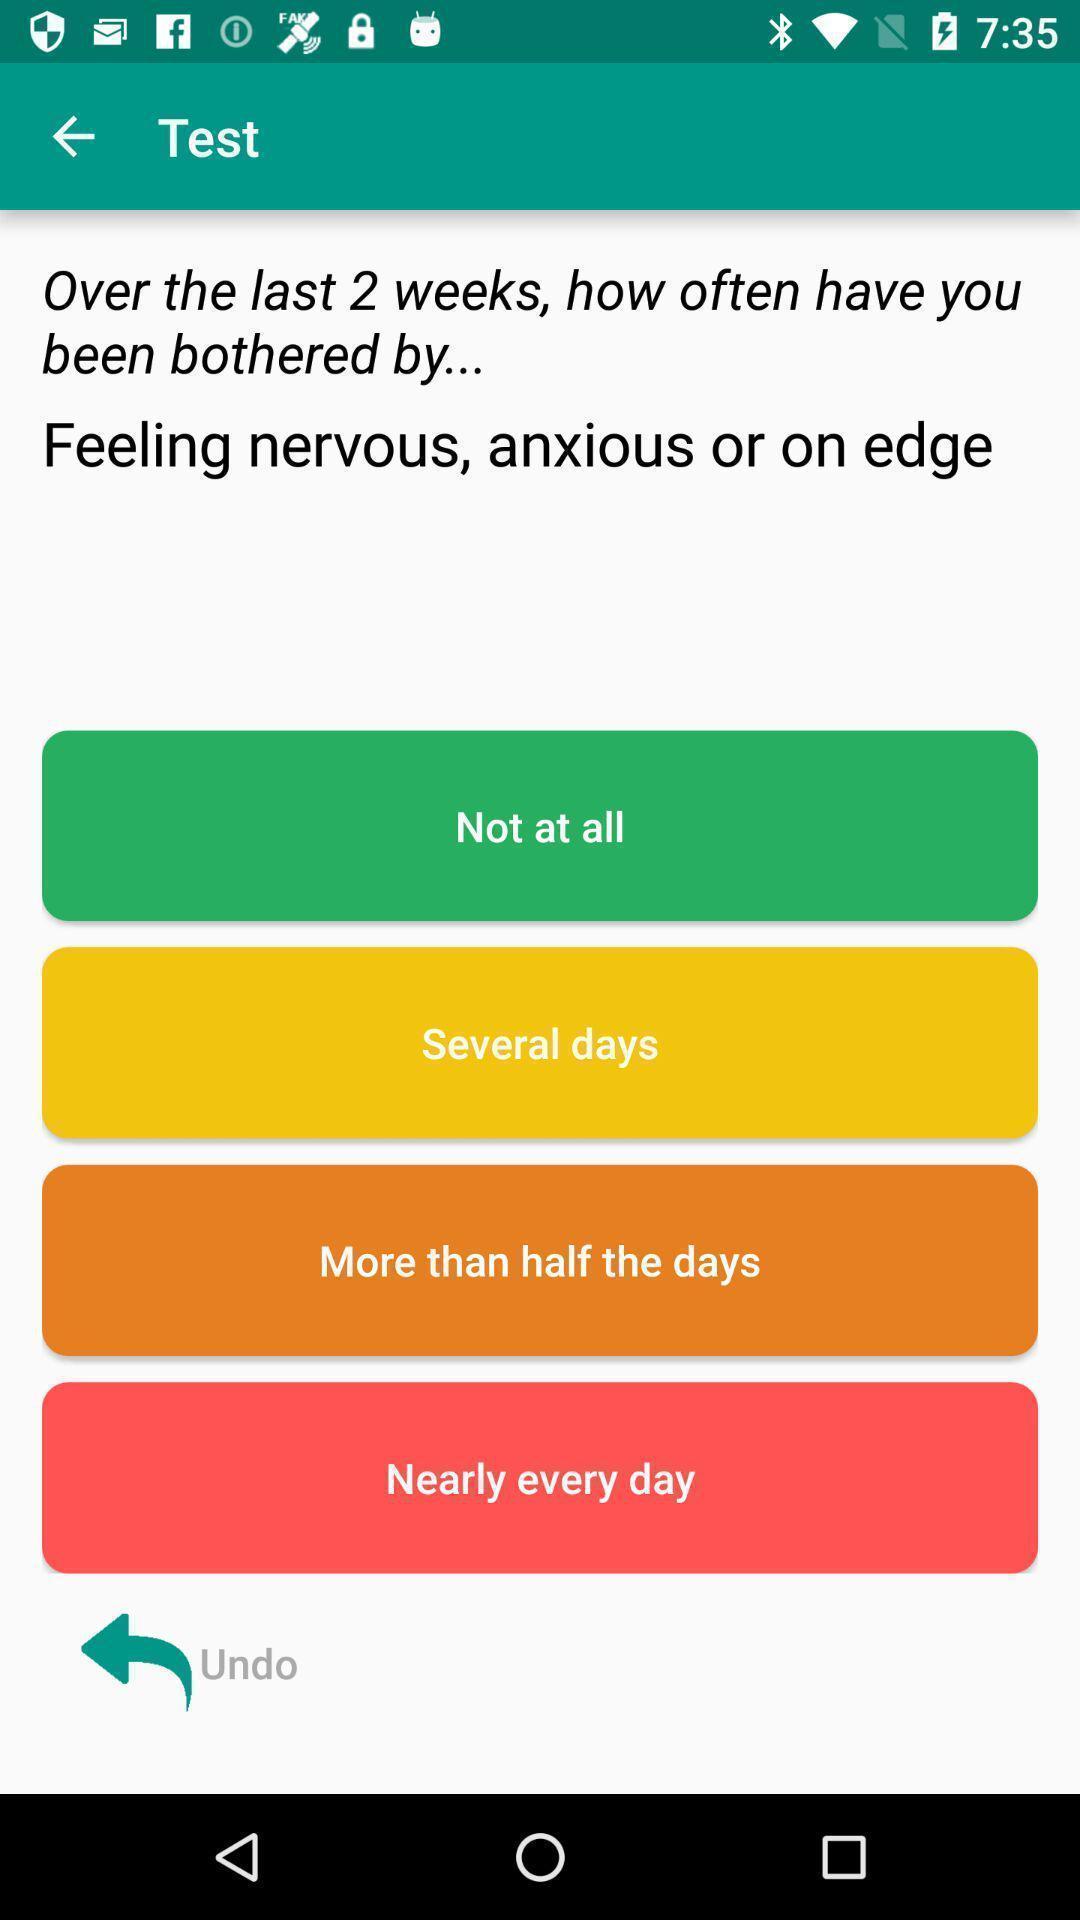Provide a textual representation of this image. Screen display about test page in anxiety app. 